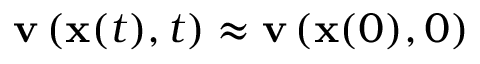Convert formula to latex. <formula><loc_0><loc_0><loc_500><loc_500>v \left ( x ( t ) , t \right ) \approx v \left ( x ( 0 ) , 0 \right )</formula> 